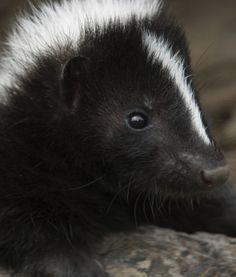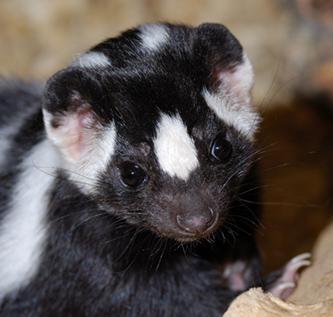The first image is the image on the left, the second image is the image on the right. Considering the images on both sides, is "The left image features a skunk with a thin white stripe down its rightward-turned head, and the right image features a forward-facing skunk that does not have white fur covering the top of its head." valid? Answer yes or no. Yes. 